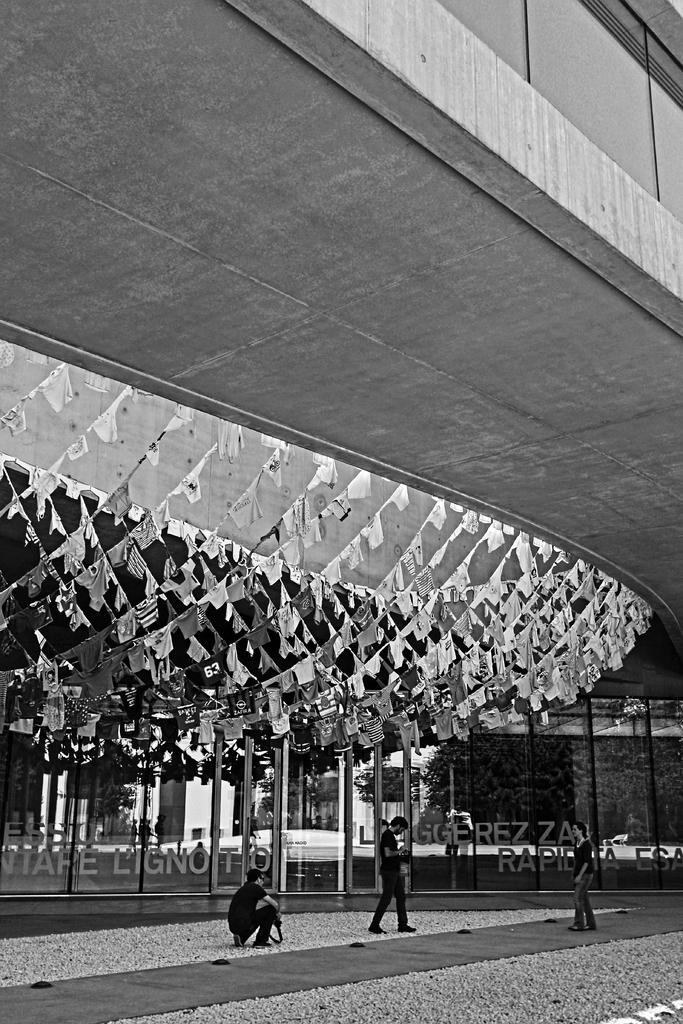How many people are in the image? There are three people on the ground in the image. What can be seen in the image besides the people? Decorative flags, a building, trees, and some unspecified objects are visible in the image. Can you describe the building in the image? The building is present in the image, but its specific characteristics are not mentioned in the provided facts. What is visible in the background of the image? Trees and some unspecified objects are visible in the background of the image. How many spiders are crawling on the roof in the image? There is no roof or spiders present in the image. 